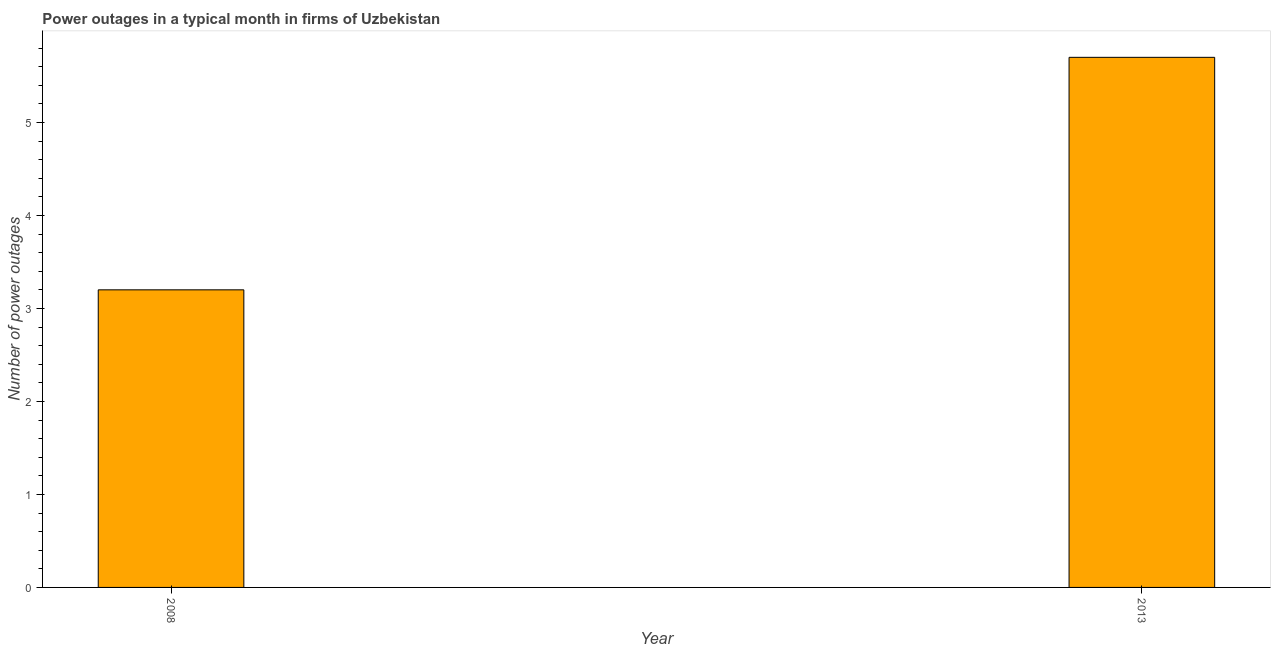Does the graph contain any zero values?
Make the answer very short. No. Does the graph contain grids?
Provide a short and direct response. No. What is the title of the graph?
Your response must be concise. Power outages in a typical month in firms of Uzbekistan. What is the label or title of the Y-axis?
Your answer should be very brief. Number of power outages. What is the number of power outages in 2013?
Your answer should be very brief. 5.7. Across all years, what is the minimum number of power outages?
Offer a terse response. 3.2. What is the sum of the number of power outages?
Ensure brevity in your answer.  8.9. What is the average number of power outages per year?
Provide a short and direct response. 4.45. What is the median number of power outages?
Give a very brief answer. 4.45. In how many years, is the number of power outages greater than 1.6 ?
Your answer should be compact. 2. What is the ratio of the number of power outages in 2008 to that in 2013?
Offer a very short reply. 0.56. Is the number of power outages in 2008 less than that in 2013?
Offer a terse response. Yes. How many bars are there?
Give a very brief answer. 2. Are all the bars in the graph horizontal?
Offer a very short reply. No. How many years are there in the graph?
Ensure brevity in your answer.  2. Are the values on the major ticks of Y-axis written in scientific E-notation?
Provide a succinct answer. No. What is the Number of power outages of 2013?
Offer a very short reply. 5.7. What is the ratio of the Number of power outages in 2008 to that in 2013?
Give a very brief answer. 0.56. 